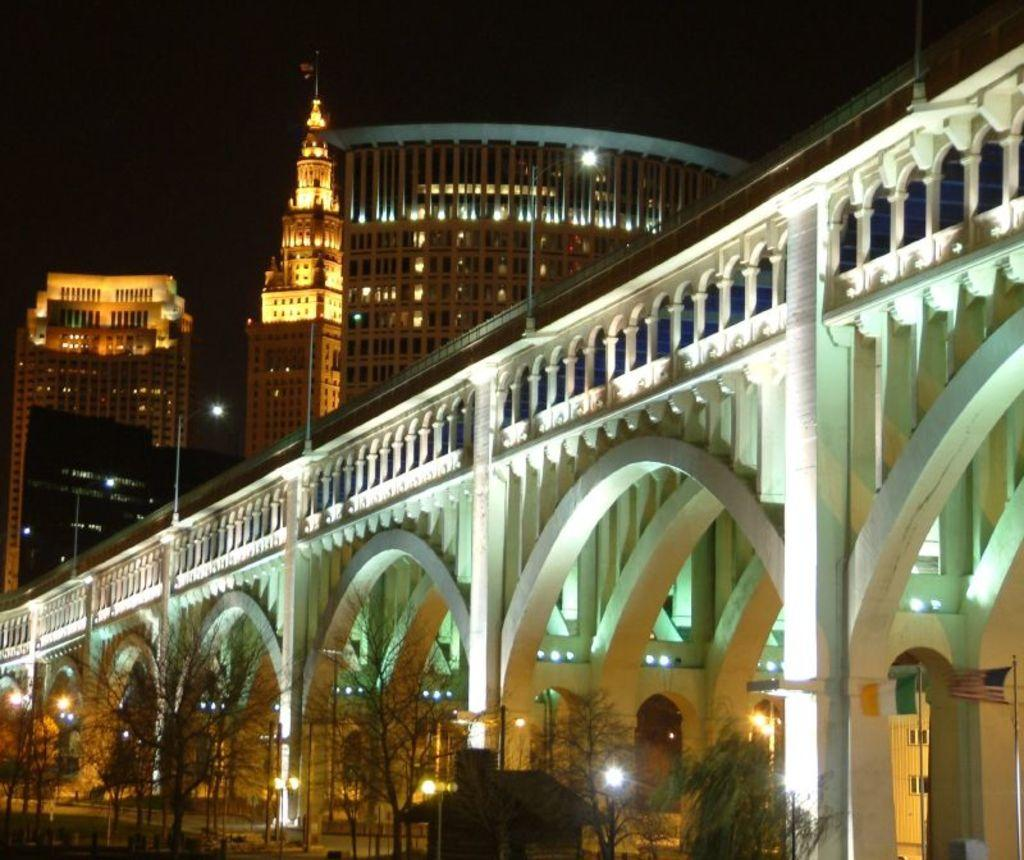What is the color and type of building in the foreground of the image? There is a white color arch building in the image. What is located in front of the building? There are dry trees in front of the building. What can be seen in the background of the image? There is a brown color big building and a tower in the background. What type of marble is used to construct the arch of the building in the image? There is no mention of marble being used in the construction of the building in the image. 